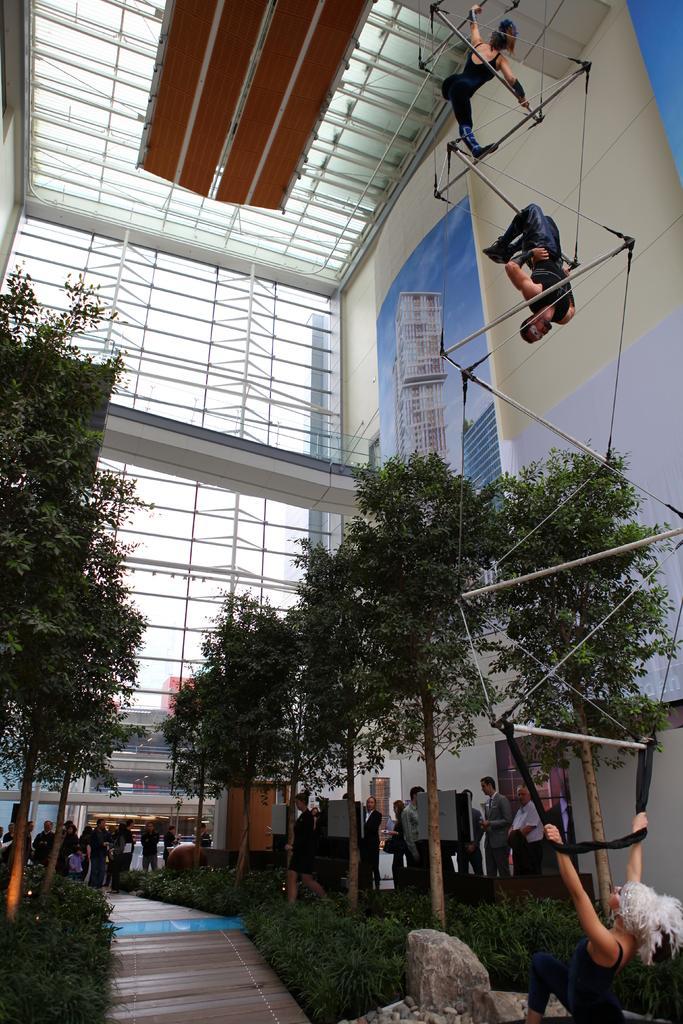Could you give a brief overview of what you see in this image? In this picture there are three persons who are doing the stunts and they are wearing the same black dress. At the bottom background I can see many people were standing near to the door, trees, plants and grass. In the background I can see the sky, banners, building and other objects. 